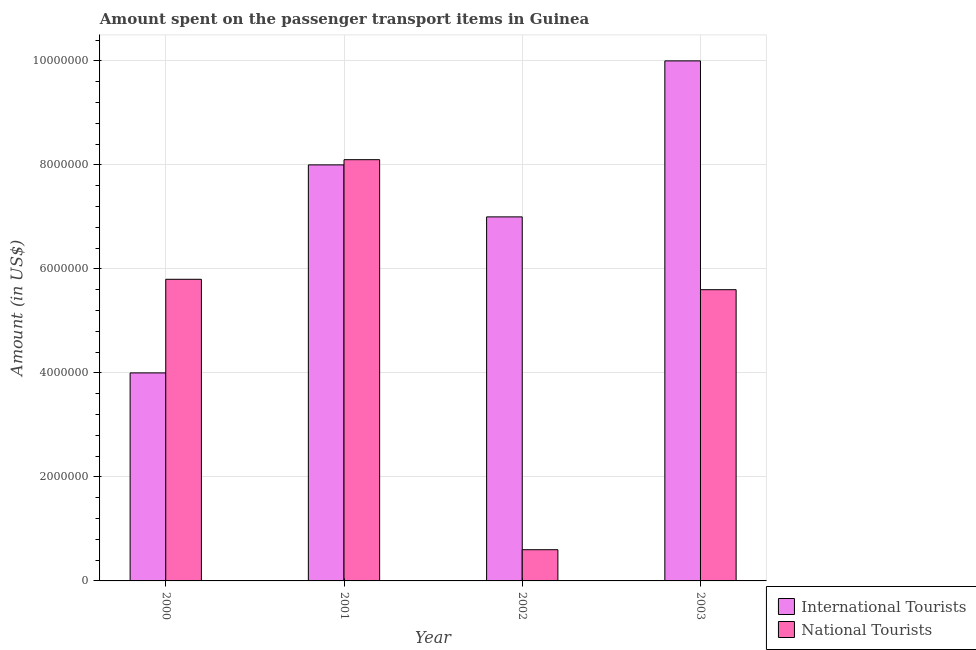How many different coloured bars are there?
Your answer should be very brief. 2. How many bars are there on the 3rd tick from the left?
Ensure brevity in your answer.  2. How many bars are there on the 3rd tick from the right?
Give a very brief answer. 2. In how many cases, is the number of bars for a given year not equal to the number of legend labels?
Your answer should be compact. 0. What is the amount spent on transport items of national tourists in 2000?
Your answer should be compact. 5.80e+06. Across all years, what is the maximum amount spent on transport items of national tourists?
Your answer should be very brief. 8.10e+06. Across all years, what is the minimum amount spent on transport items of national tourists?
Provide a short and direct response. 6.00e+05. In which year was the amount spent on transport items of international tourists maximum?
Give a very brief answer. 2003. What is the total amount spent on transport items of national tourists in the graph?
Your answer should be compact. 2.01e+07. What is the difference between the amount spent on transport items of international tourists in 2001 and that in 2003?
Give a very brief answer. -2.00e+06. What is the difference between the amount spent on transport items of international tourists in 2000 and the amount spent on transport items of national tourists in 2002?
Keep it short and to the point. -3.00e+06. What is the average amount spent on transport items of national tourists per year?
Your answer should be compact. 5.02e+06. In the year 2001, what is the difference between the amount spent on transport items of national tourists and amount spent on transport items of international tourists?
Give a very brief answer. 0. In how many years, is the amount spent on transport items of national tourists greater than 7200000 US$?
Your response must be concise. 1. What is the ratio of the amount spent on transport items of international tourists in 2000 to that in 2001?
Your answer should be very brief. 0.5. Is the difference between the amount spent on transport items of international tourists in 2001 and 2002 greater than the difference between the amount spent on transport items of national tourists in 2001 and 2002?
Ensure brevity in your answer.  No. What is the difference between the highest and the second highest amount spent on transport items of national tourists?
Your answer should be compact. 2.30e+06. What is the difference between the highest and the lowest amount spent on transport items of national tourists?
Offer a very short reply. 7.50e+06. In how many years, is the amount spent on transport items of national tourists greater than the average amount spent on transport items of national tourists taken over all years?
Keep it short and to the point. 3. What does the 1st bar from the left in 2001 represents?
Make the answer very short. International Tourists. What does the 1st bar from the right in 2002 represents?
Offer a terse response. National Tourists. How many bars are there?
Your response must be concise. 8. Are all the bars in the graph horizontal?
Your response must be concise. No. How many years are there in the graph?
Ensure brevity in your answer.  4. What is the difference between two consecutive major ticks on the Y-axis?
Make the answer very short. 2.00e+06. Does the graph contain any zero values?
Ensure brevity in your answer.  No. Where does the legend appear in the graph?
Your answer should be compact. Bottom right. What is the title of the graph?
Make the answer very short. Amount spent on the passenger transport items in Guinea. What is the label or title of the X-axis?
Your answer should be very brief. Year. What is the label or title of the Y-axis?
Offer a terse response. Amount (in US$). What is the Amount (in US$) of International Tourists in 2000?
Provide a succinct answer. 4.00e+06. What is the Amount (in US$) in National Tourists in 2000?
Offer a terse response. 5.80e+06. What is the Amount (in US$) of National Tourists in 2001?
Your answer should be very brief. 8.10e+06. What is the Amount (in US$) of International Tourists in 2002?
Provide a short and direct response. 7.00e+06. What is the Amount (in US$) in International Tourists in 2003?
Give a very brief answer. 1.00e+07. What is the Amount (in US$) in National Tourists in 2003?
Offer a very short reply. 5.60e+06. Across all years, what is the maximum Amount (in US$) in National Tourists?
Ensure brevity in your answer.  8.10e+06. What is the total Amount (in US$) in International Tourists in the graph?
Your answer should be very brief. 2.90e+07. What is the total Amount (in US$) of National Tourists in the graph?
Offer a terse response. 2.01e+07. What is the difference between the Amount (in US$) in National Tourists in 2000 and that in 2001?
Provide a succinct answer. -2.30e+06. What is the difference between the Amount (in US$) of National Tourists in 2000 and that in 2002?
Your answer should be compact. 5.20e+06. What is the difference between the Amount (in US$) in International Tourists in 2000 and that in 2003?
Provide a succinct answer. -6.00e+06. What is the difference between the Amount (in US$) of International Tourists in 2001 and that in 2002?
Your answer should be compact. 1.00e+06. What is the difference between the Amount (in US$) of National Tourists in 2001 and that in 2002?
Ensure brevity in your answer.  7.50e+06. What is the difference between the Amount (in US$) of International Tourists in 2001 and that in 2003?
Your response must be concise. -2.00e+06. What is the difference between the Amount (in US$) of National Tourists in 2001 and that in 2003?
Give a very brief answer. 2.50e+06. What is the difference between the Amount (in US$) of International Tourists in 2002 and that in 2003?
Keep it short and to the point. -3.00e+06. What is the difference between the Amount (in US$) of National Tourists in 2002 and that in 2003?
Your answer should be compact. -5.00e+06. What is the difference between the Amount (in US$) in International Tourists in 2000 and the Amount (in US$) in National Tourists in 2001?
Provide a succinct answer. -4.10e+06. What is the difference between the Amount (in US$) in International Tourists in 2000 and the Amount (in US$) in National Tourists in 2002?
Your answer should be compact. 3.40e+06. What is the difference between the Amount (in US$) of International Tourists in 2000 and the Amount (in US$) of National Tourists in 2003?
Your answer should be compact. -1.60e+06. What is the difference between the Amount (in US$) of International Tourists in 2001 and the Amount (in US$) of National Tourists in 2002?
Make the answer very short. 7.40e+06. What is the difference between the Amount (in US$) of International Tourists in 2001 and the Amount (in US$) of National Tourists in 2003?
Your answer should be compact. 2.40e+06. What is the difference between the Amount (in US$) of International Tourists in 2002 and the Amount (in US$) of National Tourists in 2003?
Provide a succinct answer. 1.40e+06. What is the average Amount (in US$) in International Tourists per year?
Offer a very short reply. 7.25e+06. What is the average Amount (in US$) in National Tourists per year?
Keep it short and to the point. 5.02e+06. In the year 2000, what is the difference between the Amount (in US$) in International Tourists and Amount (in US$) in National Tourists?
Provide a succinct answer. -1.80e+06. In the year 2001, what is the difference between the Amount (in US$) of International Tourists and Amount (in US$) of National Tourists?
Offer a terse response. -1.00e+05. In the year 2002, what is the difference between the Amount (in US$) in International Tourists and Amount (in US$) in National Tourists?
Make the answer very short. 6.40e+06. In the year 2003, what is the difference between the Amount (in US$) in International Tourists and Amount (in US$) in National Tourists?
Make the answer very short. 4.40e+06. What is the ratio of the Amount (in US$) in International Tourists in 2000 to that in 2001?
Provide a succinct answer. 0.5. What is the ratio of the Amount (in US$) of National Tourists in 2000 to that in 2001?
Give a very brief answer. 0.72. What is the ratio of the Amount (in US$) of International Tourists in 2000 to that in 2002?
Offer a terse response. 0.57. What is the ratio of the Amount (in US$) in National Tourists in 2000 to that in 2002?
Provide a succinct answer. 9.67. What is the ratio of the Amount (in US$) in National Tourists in 2000 to that in 2003?
Offer a terse response. 1.04. What is the ratio of the Amount (in US$) in International Tourists in 2001 to that in 2002?
Ensure brevity in your answer.  1.14. What is the ratio of the Amount (in US$) of National Tourists in 2001 to that in 2002?
Offer a terse response. 13.5. What is the ratio of the Amount (in US$) in National Tourists in 2001 to that in 2003?
Your response must be concise. 1.45. What is the ratio of the Amount (in US$) in International Tourists in 2002 to that in 2003?
Give a very brief answer. 0.7. What is the ratio of the Amount (in US$) of National Tourists in 2002 to that in 2003?
Make the answer very short. 0.11. What is the difference between the highest and the second highest Amount (in US$) in International Tourists?
Your answer should be very brief. 2.00e+06. What is the difference between the highest and the second highest Amount (in US$) in National Tourists?
Your answer should be very brief. 2.30e+06. What is the difference between the highest and the lowest Amount (in US$) in International Tourists?
Offer a terse response. 6.00e+06. What is the difference between the highest and the lowest Amount (in US$) of National Tourists?
Offer a terse response. 7.50e+06. 